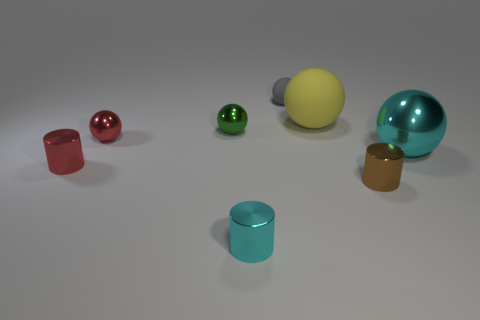What shape is the tiny cyan object? cylinder 